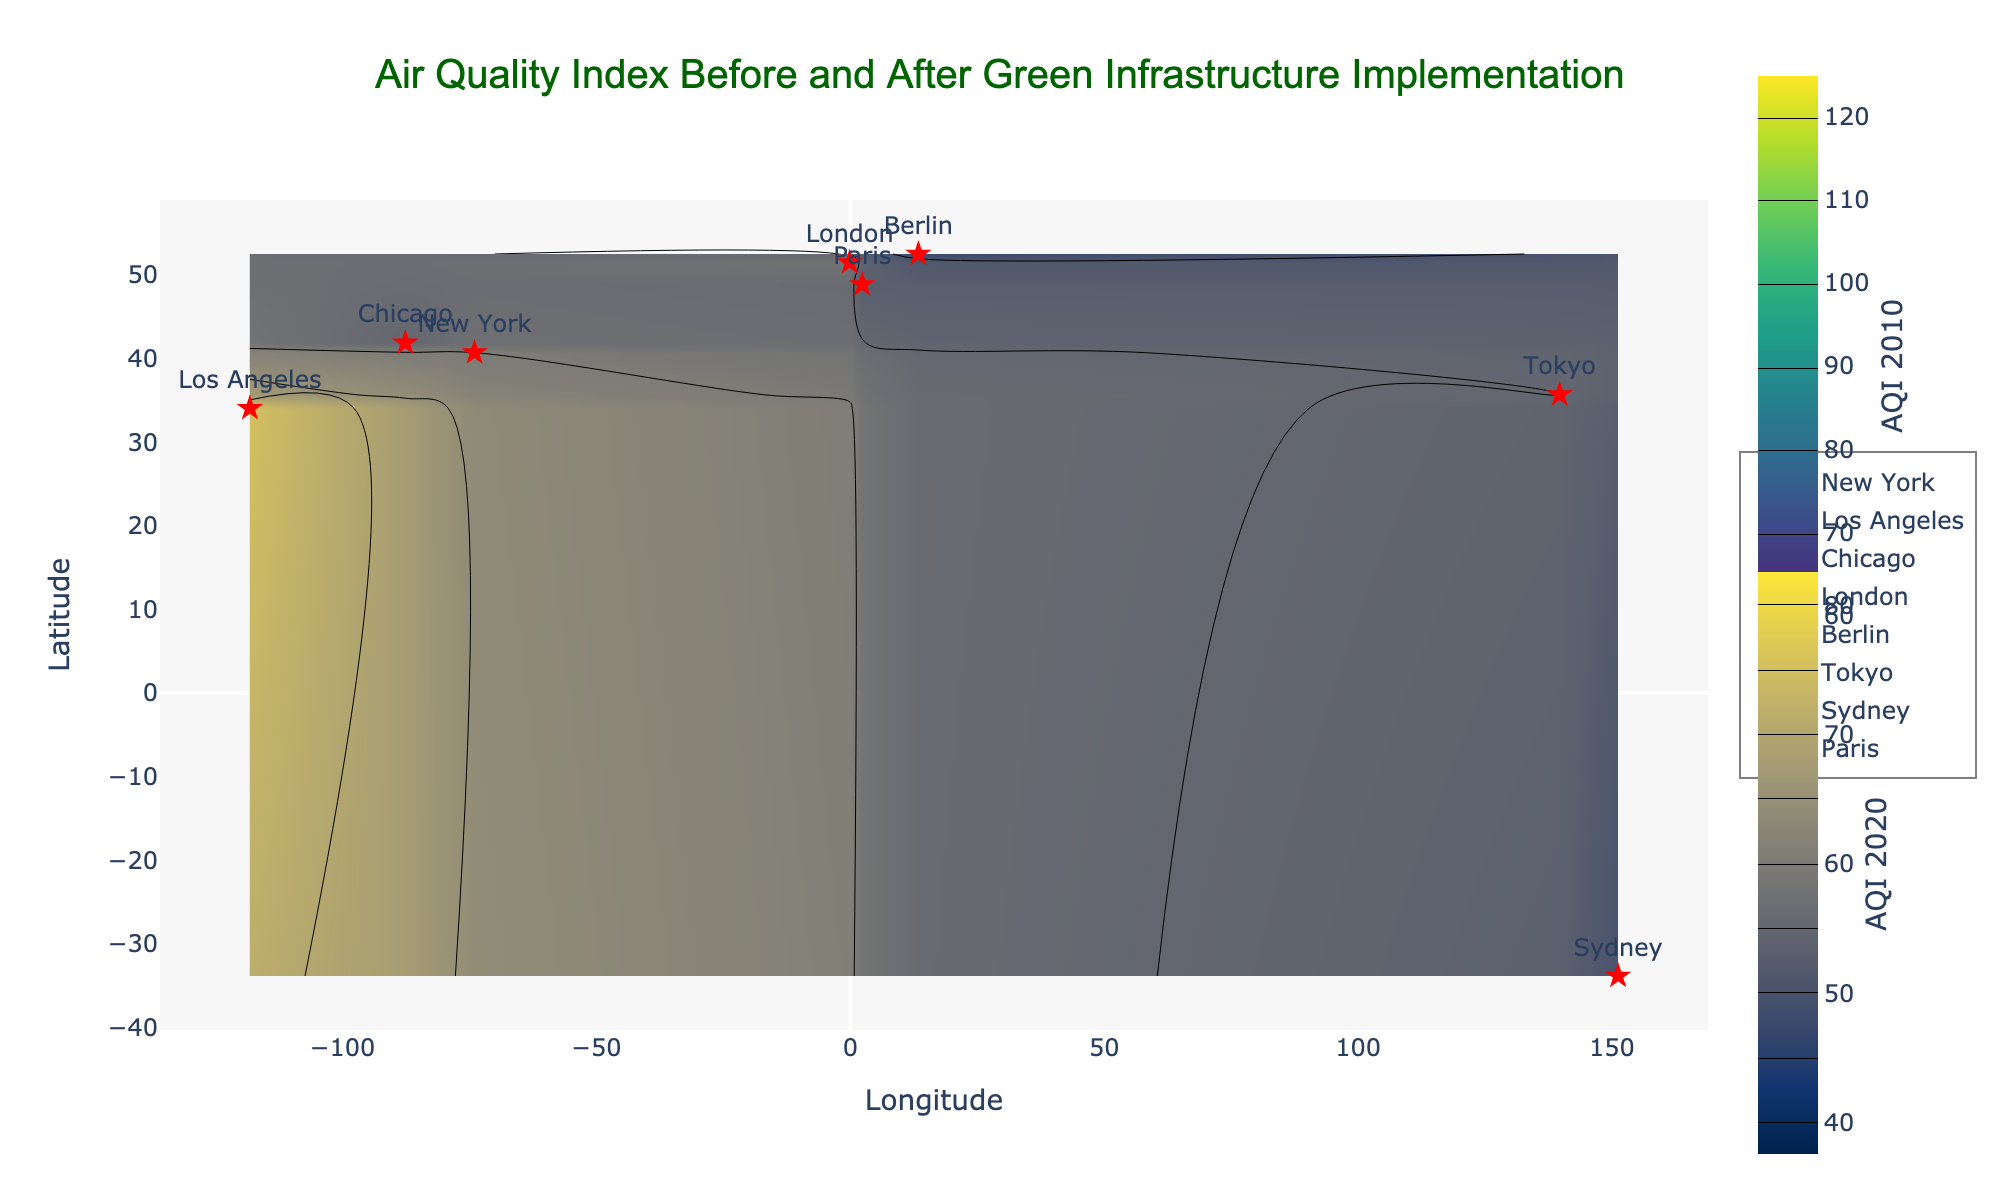What is the title of the figure? The title is usually located at the top center of the figure. In this case, it reads "Air Quality Index Before and After Green Infrastructure Implementation."
Answer: Air Quality Index Before and After Green Infrastructure Implementation What do the color bars represent? There are two color bars present in the figure. The one on the top right represents the "AQI 2010," and the one on the bottom right represents the "AQI 2020."
Answer: AQI 2010 and AQI 2020 Which city had the highest Air Quality Index (AQI) in 2010? By looking at the contour plot for 2010, Los Angeles has the highest value in the given dataset with an AQI of 110.
Answer: Los Angeles Which city had the lowest AQI in 2020? According to the data points marked on the contour plot for 2020, Berlin has the lowest AQI with a value of 48.
Answer: Berlin How did the air quality in Tokyo change from 2010 to 2020? In 2010, the AQI for Tokyo was 81, and in 2020 it was 55. To find the change, subtract the 2020 AQI from the 2010 AQI: 81 - 55 = 26.
Answer: 26 What is the range of AQI values in 2020? The contour lines for 2020 indicate AQI values ranging from 40 to 80.
Answer: 40 to 80 Compare the AQI in New York between 2010 and 2020. In the figure, New York's AQI in 2010 is 85, and in 2020 it is 60. The reduction in AQI can be calculated by 85 - 60 = 25.
Answer: The AQI decreased by 25 Which city showed the most significant improvement in AQI after implementing green infrastructure? By observing the differences between the 2010 and 2020 figures, Los Angeles showed a significant improvement, with a decrease of 110 - 75 = 35.
Answer: Los Angeles What is the approximate latitude and longitude of Berlin shown in the contour plot? The contour plot shows Berlin at roughly 52.5200° N latitude and 13.4050° E longitude.
Answer: 52.5200° N, 13.4050° E 